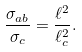Convert formula to latex. <formula><loc_0><loc_0><loc_500><loc_500>\frac { \sigma _ { a b } } { \sigma _ { c } } = \frac { \ell ^ { 2 } } { \ell _ { c } ^ { 2 } } .</formula> 